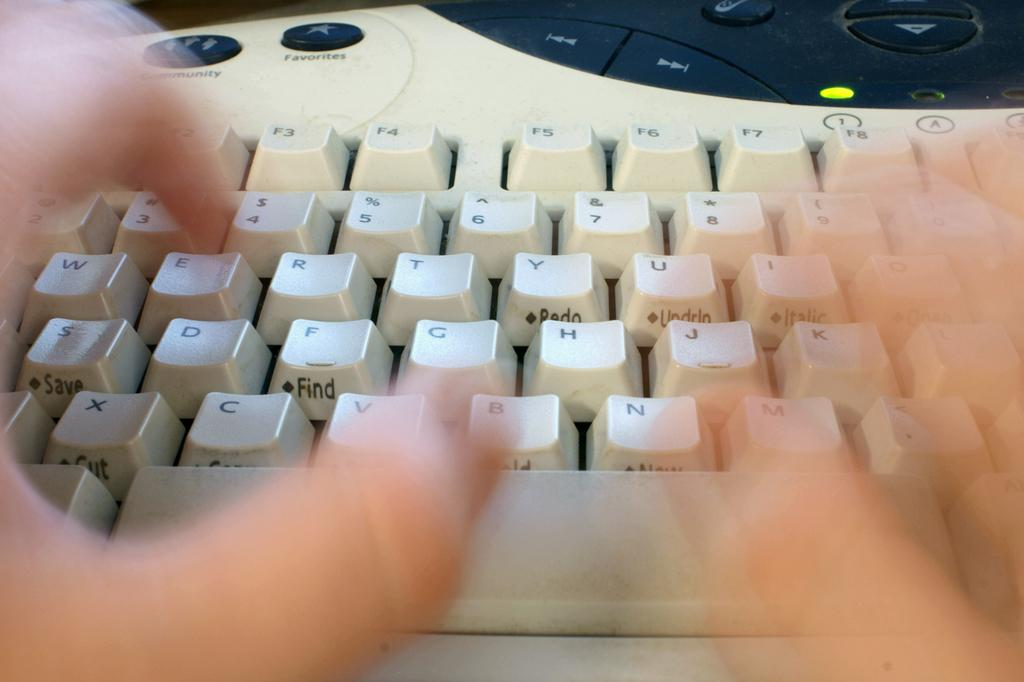<image>
Present a compact description of the photo's key features. A person is typing at a keyboard that has a community and favorites button. 